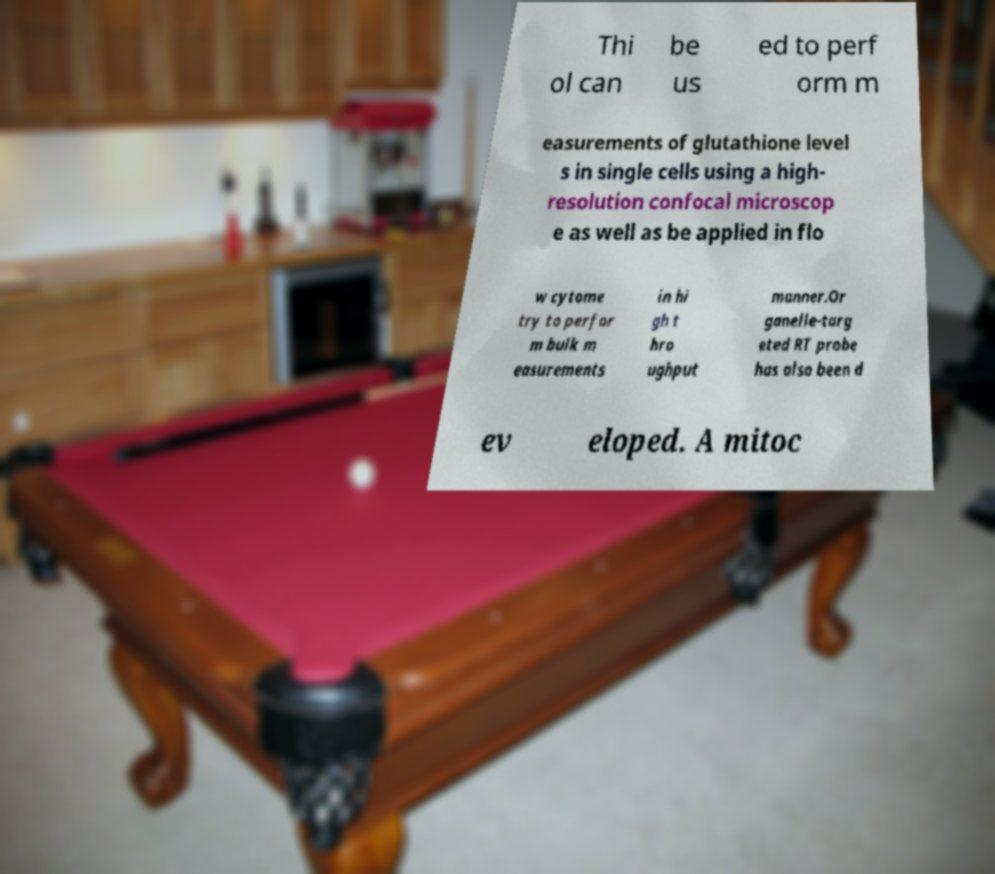There's text embedded in this image that I need extracted. Can you transcribe it verbatim? Thi ol can be us ed to perf orm m easurements of glutathione level s in single cells using a high- resolution confocal microscop e as well as be applied in flo w cytome try to perfor m bulk m easurements in hi gh t hro ughput manner.Or ganelle-targ eted RT probe has also been d ev eloped. A mitoc 